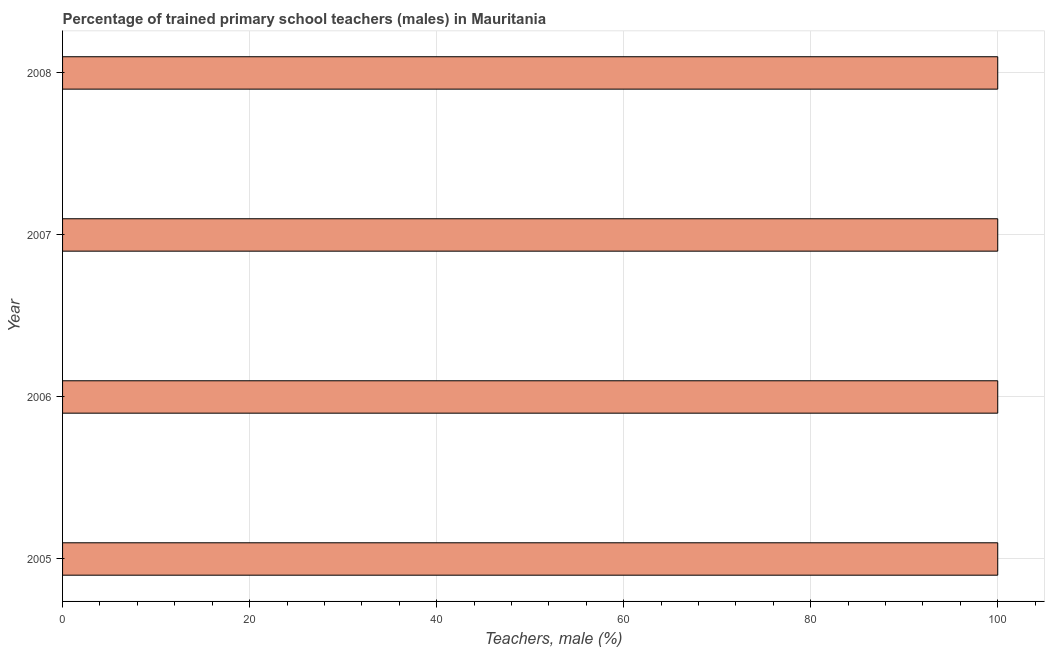Does the graph contain any zero values?
Ensure brevity in your answer.  No. What is the title of the graph?
Offer a terse response. Percentage of trained primary school teachers (males) in Mauritania. What is the label or title of the X-axis?
Your answer should be compact. Teachers, male (%). What is the percentage of trained male teachers in 2008?
Offer a terse response. 100. Across all years, what is the maximum percentage of trained male teachers?
Provide a succinct answer. 100. Across all years, what is the minimum percentage of trained male teachers?
Your answer should be compact. 100. What is the sum of the percentage of trained male teachers?
Provide a short and direct response. 400. What is the difference between the percentage of trained male teachers in 2005 and 2008?
Provide a succinct answer. 0. What is the average percentage of trained male teachers per year?
Your response must be concise. 100. What is the median percentage of trained male teachers?
Offer a very short reply. 100. In how many years, is the percentage of trained male teachers greater than 8 %?
Ensure brevity in your answer.  4. Do a majority of the years between 2008 and 2006 (inclusive) have percentage of trained male teachers greater than 96 %?
Your response must be concise. Yes. What is the ratio of the percentage of trained male teachers in 2005 to that in 2007?
Provide a short and direct response. 1. Is the percentage of trained male teachers in 2005 less than that in 2006?
Your answer should be compact. No. In how many years, is the percentage of trained male teachers greater than the average percentage of trained male teachers taken over all years?
Provide a short and direct response. 0. How many bars are there?
Make the answer very short. 4. Are all the bars in the graph horizontal?
Your answer should be compact. Yes. How many years are there in the graph?
Offer a terse response. 4. What is the difference between two consecutive major ticks on the X-axis?
Your response must be concise. 20. What is the Teachers, male (%) of 2008?
Offer a terse response. 100. What is the difference between the Teachers, male (%) in 2005 and 2006?
Your response must be concise. 0. What is the difference between the Teachers, male (%) in 2005 and 2008?
Your answer should be compact. 0. What is the difference between the Teachers, male (%) in 2006 and 2008?
Your answer should be very brief. 0. What is the difference between the Teachers, male (%) in 2007 and 2008?
Your response must be concise. 0. What is the ratio of the Teachers, male (%) in 2005 to that in 2007?
Your answer should be very brief. 1. What is the ratio of the Teachers, male (%) in 2007 to that in 2008?
Ensure brevity in your answer.  1. 